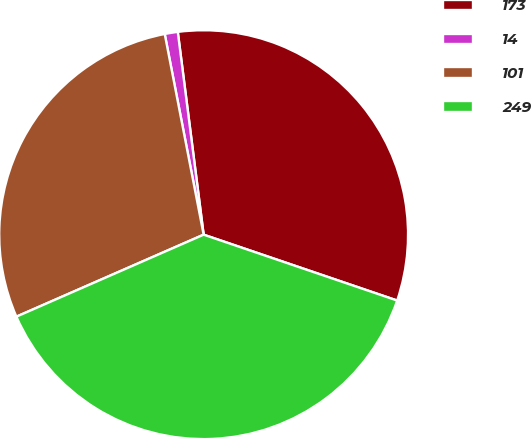Convert chart. <chart><loc_0><loc_0><loc_500><loc_500><pie_chart><fcel>173<fcel>14<fcel>101<fcel>249<nl><fcel>32.24%<fcel>1.03%<fcel>28.52%<fcel>38.21%<nl></chart> 